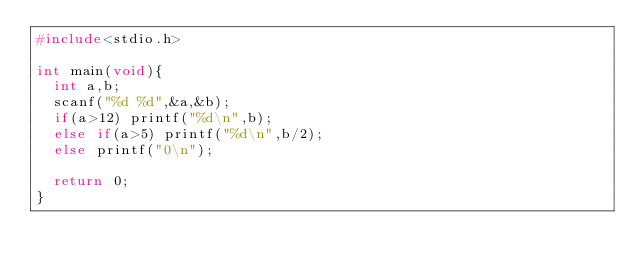<code> <loc_0><loc_0><loc_500><loc_500><_C_>#include<stdio.h>

int main(void){
  int a,b;
  scanf("%d %d",&a,&b);
  if(a>12) printf("%d\n",b);
  else if(a>5) printf("%d\n",b/2);
  else printf("0\n");

  return 0;
}
</code> 